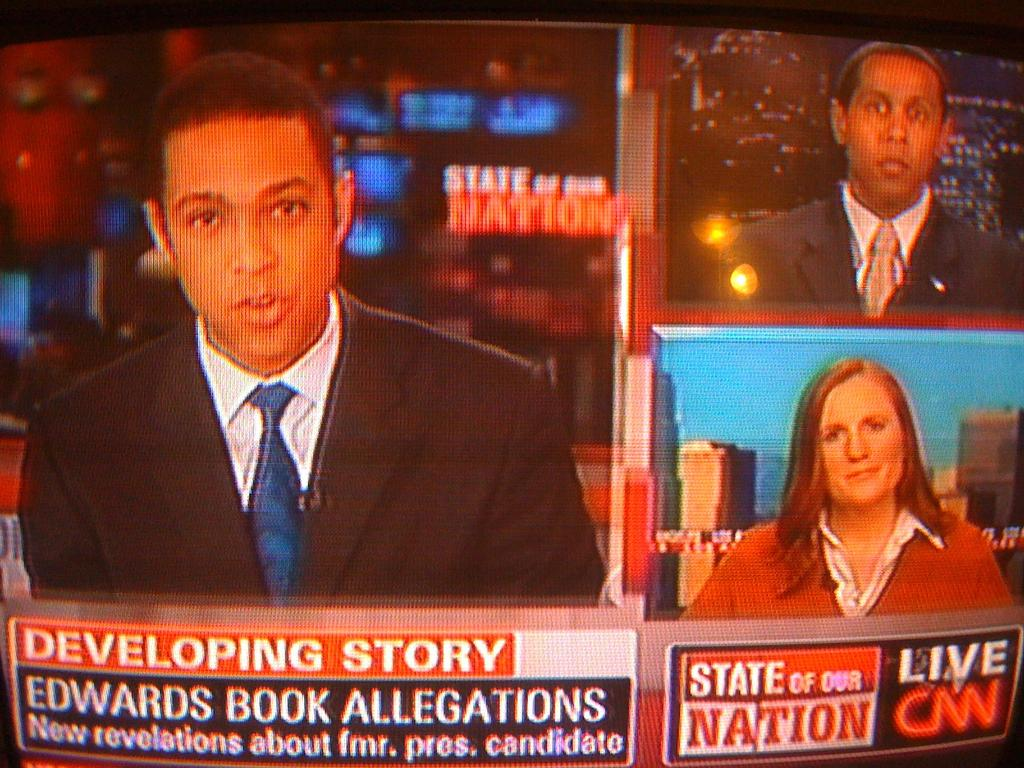What is the main subject of the image? The main subject of the image is people visible on a screen. What type of quiver can be seen in the image? There is no quiver present in the image; it only features people visible on a screen. What kind of music is being played in the image? There is no information about music in the image; it only shows people visible on a screen. 